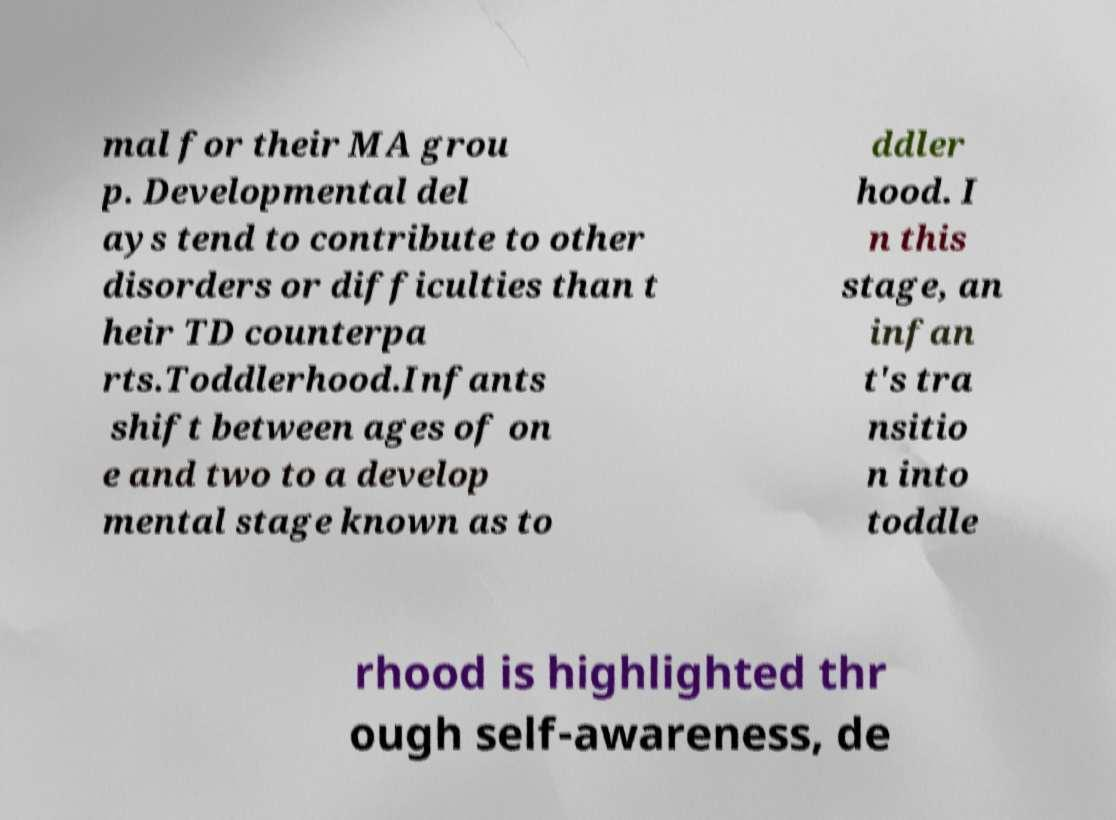There's text embedded in this image that I need extracted. Can you transcribe it verbatim? mal for their MA grou p. Developmental del ays tend to contribute to other disorders or difficulties than t heir TD counterpa rts.Toddlerhood.Infants shift between ages of on e and two to a develop mental stage known as to ddler hood. I n this stage, an infan t's tra nsitio n into toddle rhood is highlighted thr ough self-awareness, de 